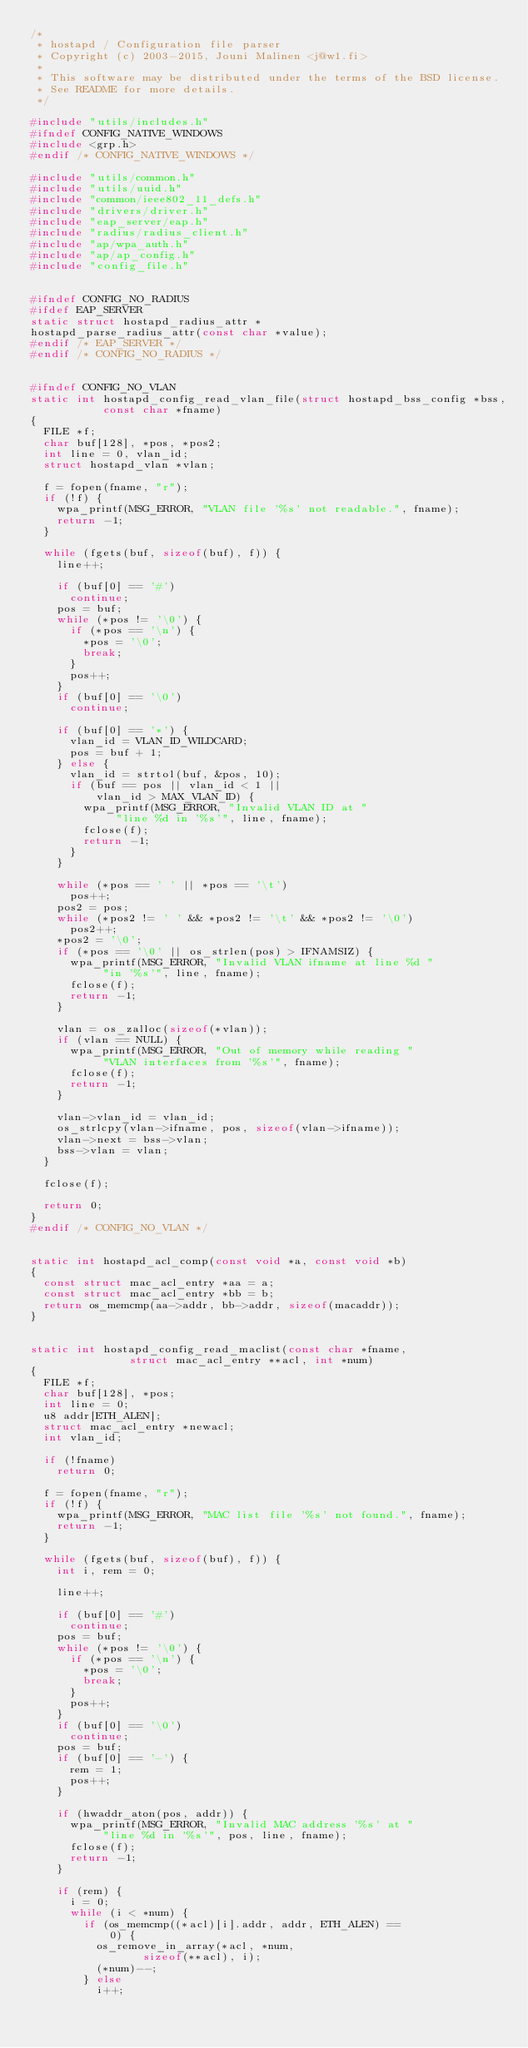Convert code to text. <code><loc_0><loc_0><loc_500><loc_500><_C_>/*
 * hostapd / Configuration file parser
 * Copyright (c) 2003-2015, Jouni Malinen <j@w1.fi>
 *
 * This software may be distributed under the terms of the BSD license.
 * See README for more details.
 */

#include "utils/includes.h"
#ifndef CONFIG_NATIVE_WINDOWS
#include <grp.h>
#endif /* CONFIG_NATIVE_WINDOWS */

#include "utils/common.h"
#include "utils/uuid.h"
#include "common/ieee802_11_defs.h"
#include "drivers/driver.h"
#include "eap_server/eap.h"
#include "radius/radius_client.h"
#include "ap/wpa_auth.h"
#include "ap/ap_config.h"
#include "config_file.h"


#ifndef CONFIG_NO_RADIUS
#ifdef EAP_SERVER
static struct hostapd_radius_attr *
hostapd_parse_radius_attr(const char *value);
#endif /* EAP_SERVER */
#endif /* CONFIG_NO_RADIUS */


#ifndef CONFIG_NO_VLAN
static int hostapd_config_read_vlan_file(struct hostapd_bss_config *bss,
					 const char *fname)
{
	FILE *f;
	char buf[128], *pos, *pos2;
	int line = 0, vlan_id;
	struct hostapd_vlan *vlan;

	f = fopen(fname, "r");
	if (!f) {
		wpa_printf(MSG_ERROR, "VLAN file '%s' not readable.", fname);
		return -1;
	}

	while (fgets(buf, sizeof(buf), f)) {
		line++;

		if (buf[0] == '#')
			continue;
		pos = buf;
		while (*pos != '\0') {
			if (*pos == '\n') {
				*pos = '\0';
				break;
			}
			pos++;
		}
		if (buf[0] == '\0')
			continue;

		if (buf[0] == '*') {
			vlan_id = VLAN_ID_WILDCARD;
			pos = buf + 1;
		} else {
			vlan_id = strtol(buf, &pos, 10);
			if (buf == pos || vlan_id < 1 ||
			    vlan_id > MAX_VLAN_ID) {
				wpa_printf(MSG_ERROR, "Invalid VLAN ID at "
					   "line %d in '%s'", line, fname);
				fclose(f);
				return -1;
			}
		}

		while (*pos == ' ' || *pos == '\t')
			pos++;
		pos2 = pos;
		while (*pos2 != ' ' && *pos2 != '\t' && *pos2 != '\0')
			pos2++;
		*pos2 = '\0';
		if (*pos == '\0' || os_strlen(pos) > IFNAMSIZ) {
			wpa_printf(MSG_ERROR, "Invalid VLAN ifname at line %d "
				   "in '%s'", line, fname);
			fclose(f);
			return -1;
		}

		vlan = os_zalloc(sizeof(*vlan));
		if (vlan == NULL) {
			wpa_printf(MSG_ERROR, "Out of memory while reading "
				   "VLAN interfaces from '%s'", fname);
			fclose(f);
			return -1;
		}

		vlan->vlan_id = vlan_id;
		os_strlcpy(vlan->ifname, pos, sizeof(vlan->ifname));
		vlan->next = bss->vlan;
		bss->vlan = vlan;
	}

	fclose(f);

	return 0;
}
#endif /* CONFIG_NO_VLAN */


static int hostapd_acl_comp(const void *a, const void *b)
{
	const struct mac_acl_entry *aa = a;
	const struct mac_acl_entry *bb = b;
	return os_memcmp(aa->addr, bb->addr, sizeof(macaddr));
}


static int hostapd_config_read_maclist(const char *fname,
				       struct mac_acl_entry **acl, int *num)
{
	FILE *f;
	char buf[128], *pos;
	int line = 0;
	u8 addr[ETH_ALEN];
	struct mac_acl_entry *newacl;
	int vlan_id;

	if (!fname)
		return 0;

	f = fopen(fname, "r");
	if (!f) {
		wpa_printf(MSG_ERROR, "MAC list file '%s' not found.", fname);
		return -1;
	}

	while (fgets(buf, sizeof(buf), f)) {
		int i, rem = 0;

		line++;

		if (buf[0] == '#')
			continue;
		pos = buf;
		while (*pos != '\0') {
			if (*pos == '\n') {
				*pos = '\0';
				break;
			}
			pos++;
		}
		if (buf[0] == '\0')
			continue;
		pos = buf;
		if (buf[0] == '-') {
			rem = 1;
			pos++;
		}

		if (hwaddr_aton(pos, addr)) {
			wpa_printf(MSG_ERROR, "Invalid MAC address '%s' at "
				   "line %d in '%s'", pos, line, fname);
			fclose(f);
			return -1;
		}

		if (rem) {
			i = 0;
			while (i < *num) {
				if (os_memcmp((*acl)[i].addr, addr, ETH_ALEN) ==
				    0) {
					os_remove_in_array(*acl, *num,
							   sizeof(**acl), i);
					(*num)--;
				} else
					i++;</code> 